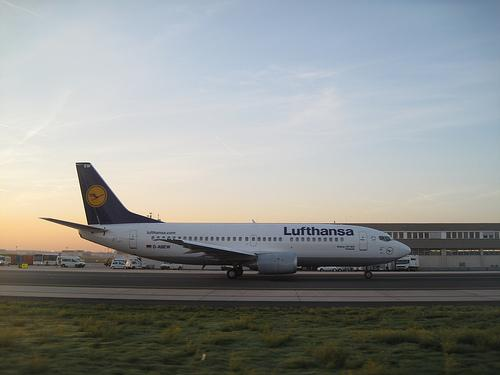Mention the central object of the image along with its color and any distinct feature present in it. The picture shows a white Lufthansa plane with a blue tail, many windows, and an engine on the runway. Describe the airplane's parts visible in the image and their respective colors. The airplane flaunts a blue tail, white wing, and a yellow decal, with green grass and a brown building in the background. Mention the colors in the image along with the main object and some components of the image. The image shows a white Lufthansa plane with a blue tail, a pink sunset, green grass, and a brown-roofed building. Give a detailed description of the airplane's components seen in the image. The plane features a blue tail with a yellow decal, a row of windows, blue writing, a jet engine, a door, front window, and a wing. Describe the atmosphere and setting of the image along with the main object and its background. A Lufthansa plane rests on the runway amidst an airport scene with a sunset, a building, and grass in the background. Give a concise description of the airplane and its noteworthy features seen in the image. The image showcases a Lufthansa plane with a blue tail, a row of windows, blue writings, and an engine on the runway. Briefly explain what is happening in the image - particularly the main object and its surrounding. The picture captures a Lufthansa plane on the airport runway with green grass and a building in its vicinity. Provide a brief description of the image, mentioning the central object and its location. A Lufthansa plane is on the runway, with a building and sunset behind it and grass in the forefront. State the primary object in the image along with its brand and any relevant company logo. A Lufthansa plane with a blue tail and the painted Lufthansa corporate logo is present in the image. Mention the main object of the image and its position in relation to the background elements. A Lufthansa plane is in front of a building, on a runway, with a sunset and green grass surrounding it. 